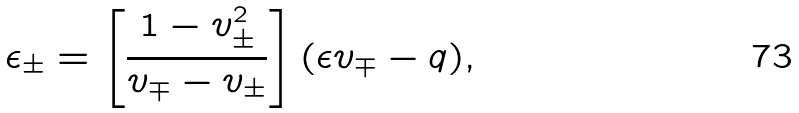Convert formula to latex. <formula><loc_0><loc_0><loc_500><loc_500>\epsilon _ { \pm } = \left [ \frac { 1 - v _ { \pm } ^ { 2 } } { v _ { \mp } - v _ { \pm } } \right ] ( \epsilon v _ { \mp } - q ) ,</formula> 